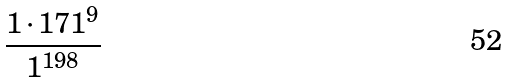<formula> <loc_0><loc_0><loc_500><loc_500>\frac { 1 \cdot 1 7 1 ^ { 9 } } { 1 ^ { 1 9 8 } }</formula> 